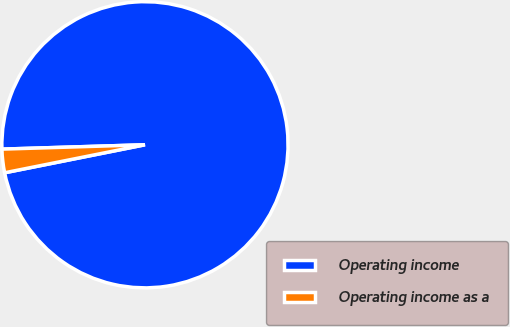Convert chart to OTSL. <chart><loc_0><loc_0><loc_500><loc_500><pie_chart><fcel>Operating income<fcel>Operating income as a<nl><fcel>97.35%<fcel>2.65%<nl></chart> 